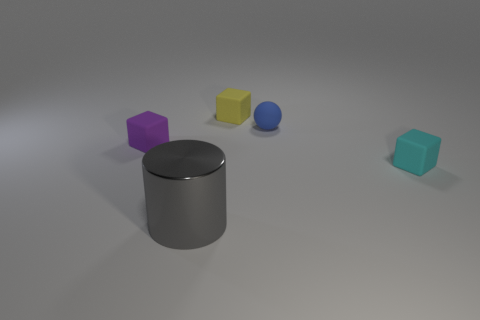What color is the rubber object that is both to the right of the yellow thing and in front of the tiny blue rubber ball?
Offer a very short reply. Cyan. Is there anything else of the same color as the cylinder?
Provide a succinct answer. No. What shape is the object in front of the tiny block that is to the right of the rubber block that is behind the tiny purple rubber thing?
Offer a very short reply. Cylinder. There is a tiny matte block in front of the tiny block that is left of the tiny yellow rubber thing; what color is it?
Your answer should be compact. Cyan. There is a cyan thing that is the same shape as the purple thing; what is its size?
Keep it short and to the point. Small. How many gray things have the same material as the blue sphere?
Make the answer very short. 0. How many small things are behind the small matte cube that is on the left side of the yellow object?
Ensure brevity in your answer.  2. Are there any large shiny things to the right of the yellow cube?
Offer a terse response. No. Does the small thing in front of the tiny purple object have the same shape as the yellow matte thing?
Give a very brief answer. Yes. What is the shape of the thing in front of the rubber cube that is on the right side of the yellow rubber object?
Your response must be concise. Cylinder. 